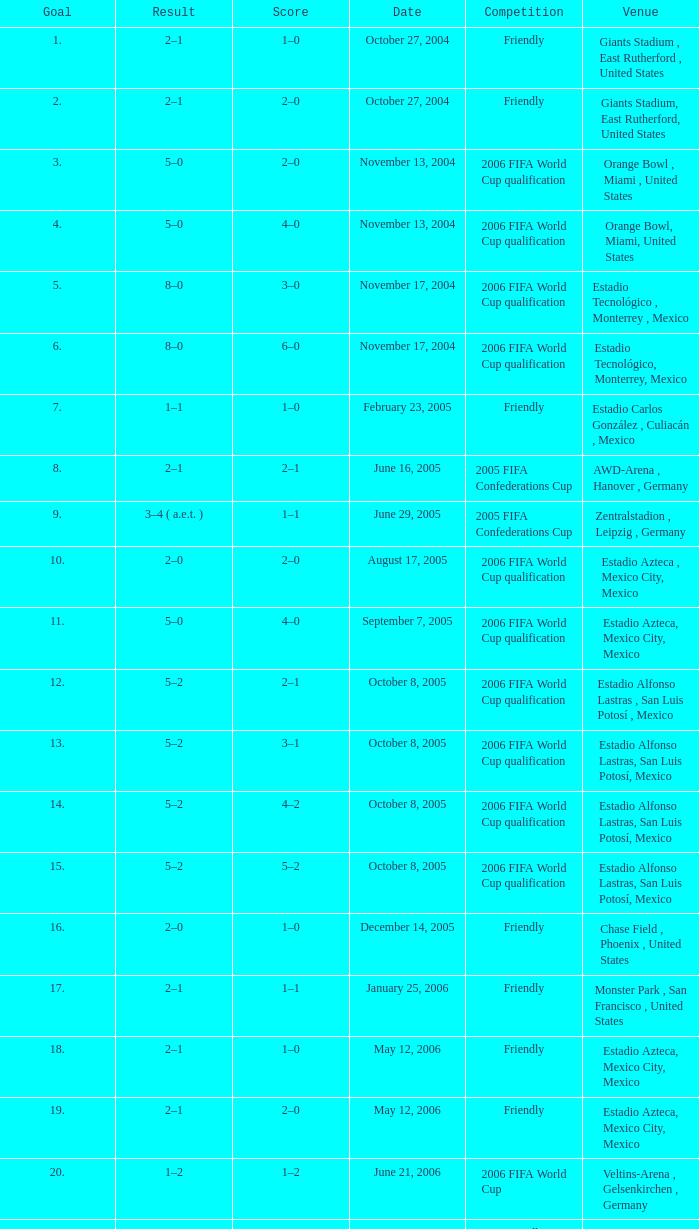Which Competition has a Venue of estadio alfonso lastras, san luis potosí, mexico, and a Goal larger than 15? Friendly. 